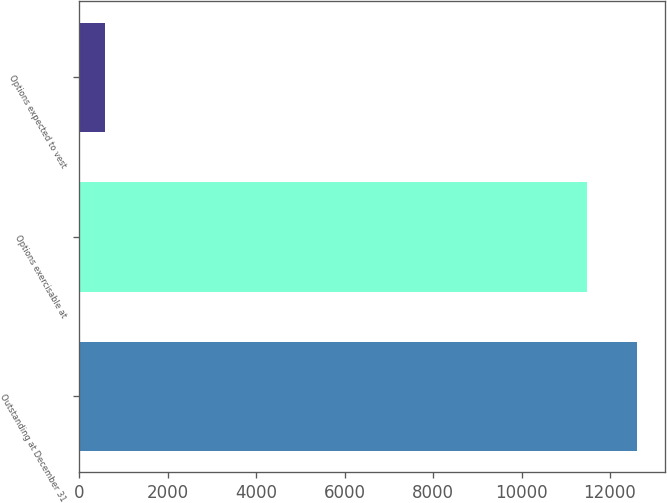Convert chart. <chart><loc_0><loc_0><loc_500><loc_500><bar_chart><fcel>Outstanding at December 31<fcel>Options exercisable at<fcel>Options expected to vest<nl><fcel>12621.1<fcel>11472<fcel>595<nl></chart> 